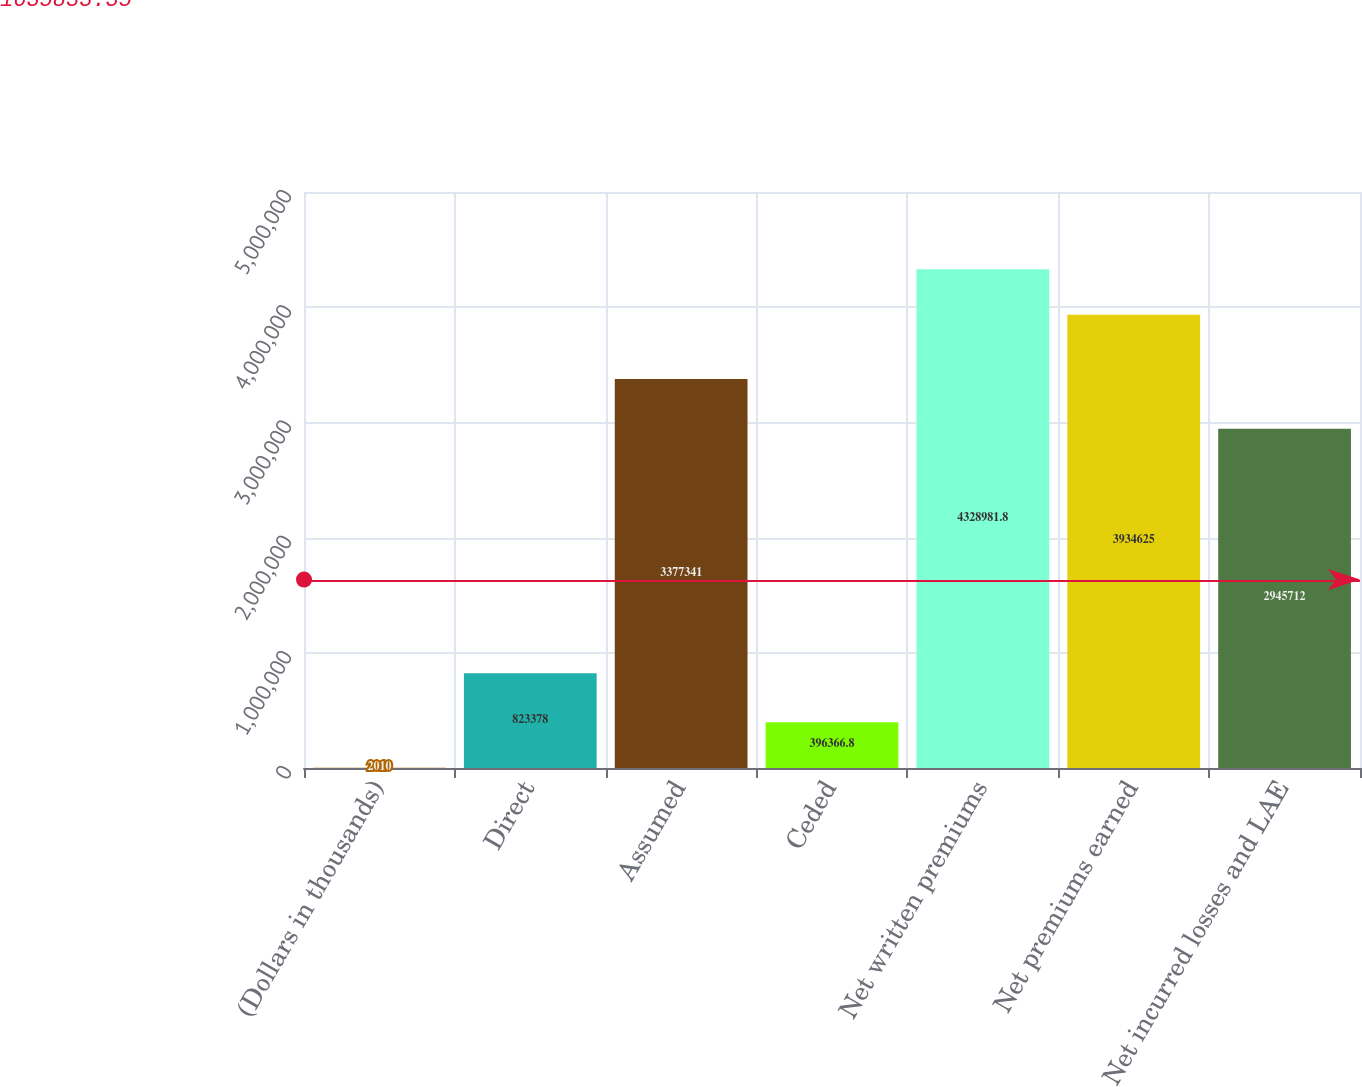Convert chart. <chart><loc_0><loc_0><loc_500><loc_500><bar_chart><fcel>(Dollars in thousands)<fcel>Direct<fcel>Assumed<fcel>Ceded<fcel>Net written premiums<fcel>Net premiums earned<fcel>Net incurred losses and LAE<nl><fcel>2010<fcel>823378<fcel>3.37734e+06<fcel>396367<fcel>4.32898e+06<fcel>3.93462e+06<fcel>2.94571e+06<nl></chart> 